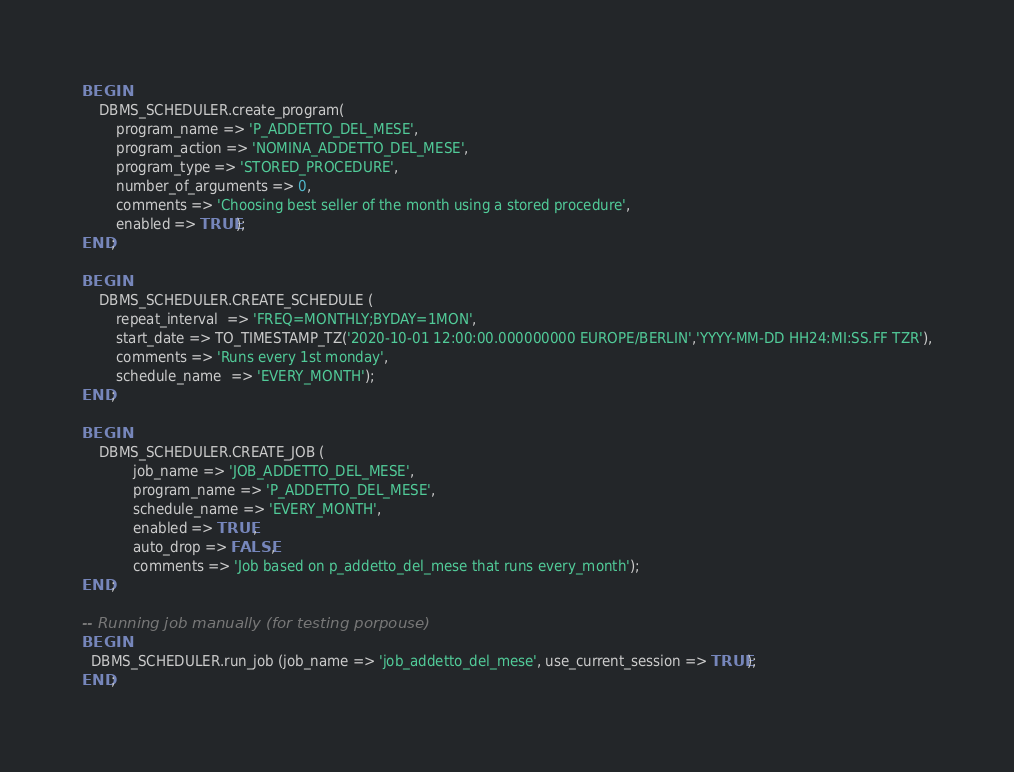Convert code to text. <code><loc_0><loc_0><loc_500><loc_500><_SQL_>BEGIN
    DBMS_SCHEDULER.create_program(
        program_name => 'P_ADDETTO_DEL_MESE',
        program_action => 'NOMINA_ADDETTO_DEL_MESE',
        program_type => 'STORED_PROCEDURE',
        number_of_arguments => 0,
        comments => 'Choosing best seller of the month using a stored procedure',
        enabled => TRUE);
END;

BEGIN
    DBMS_SCHEDULER.CREATE_SCHEDULE (
        repeat_interval  => 'FREQ=MONTHLY;BYDAY=1MON',
        start_date => TO_TIMESTAMP_TZ('2020-10-01 12:00:00.000000000 EUROPE/BERLIN','YYYY-MM-DD HH24:MI:SS.FF TZR'),
        comments => 'Runs every 1st monday',
        schedule_name  => 'EVERY_MONTH');
END;

BEGIN
    DBMS_SCHEDULER.CREATE_JOB (
            job_name => 'JOB_ADDETTO_DEL_MESE',
            program_name => 'P_ADDETTO_DEL_MESE',
            schedule_name => 'EVERY_MONTH',
            enabled => TRUE,
            auto_drop => FALSE,
            comments => 'Job based on p_addetto_del_mese that runs every_month');
END;

-- Running job manually (for testing porpouse)
BEGIN
  DBMS_SCHEDULER.run_job (job_name => 'job_addetto_del_mese', use_current_session => TRUE);
END;
</code> 